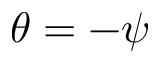Convert formula to latex. <formula><loc_0><loc_0><loc_500><loc_500>\theta = - \psi</formula> 